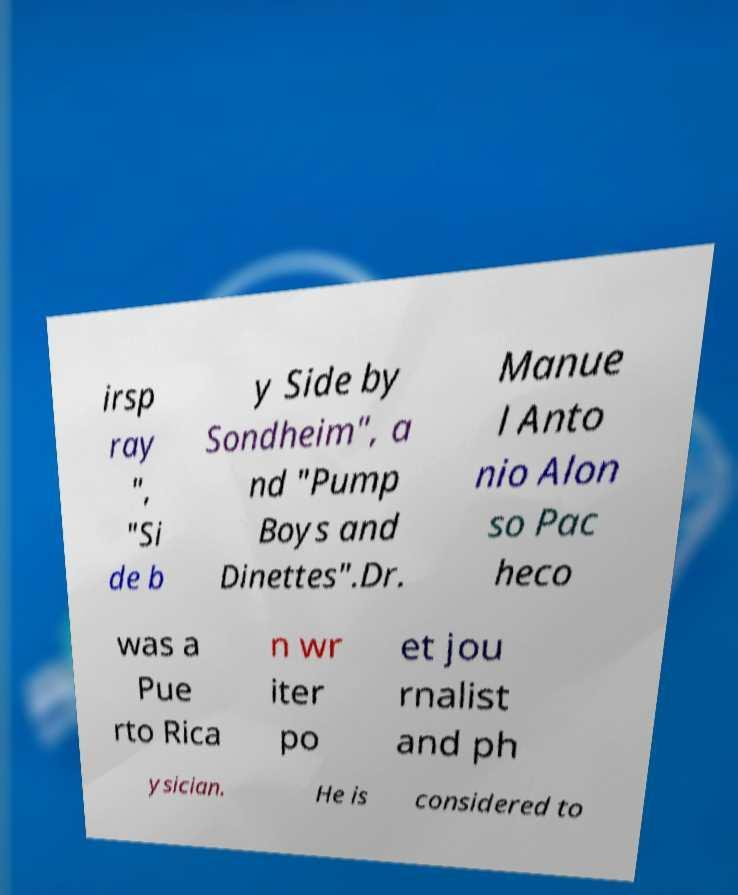I need the written content from this picture converted into text. Can you do that? irsp ray ", "Si de b y Side by Sondheim", a nd "Pump Boys and Dinettes".Dr. Manue l Anto nio Alon so Pac heco was a Pue rto Rica n wr iter po et jou rnalist and ph ysician. He is considered to 